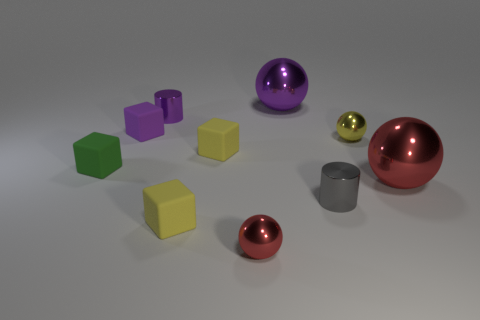What color is the other tiny metal object that is the same shape as the tiny yellow metallic thing?
Your answer should be very brief. Red. There is a matte cube that is to the left of the purple matte block; is it the same size as the large purple metallic sphere?
Offer a very short reply. No. What is the size of the metallic cylinder on the right side of the small ball that is in front of the tiny gray metallic cylinder?
Your response must be concise. Small. Is the gray cylinder made of the same material as the big thing that is behind the tiny purple rubber thing?
Ensure brevity in your answer.  Yes. Are there fewer small purple blocks behind the big purple metallic sphere than big metallic objects behind the purple matte block?
Provide a short and direct response. Yes. There is another big sphere that is the same material as the big red sphere; what is its color?
Provide a short and direct response. Purple. There is a small purple rubber cube in front of the small purple shiny thing; are there any tiny cubes that are to the right of it?
Make the answer very short. Yes. The other metallic cylinder that is the same size as the gray metal cylinder is what color?
Your answer should be very brief. Purple. What number of things are big gray spheres or big red metallic balls?
Ensure brevity in your answer.  1. What size is the purple matte cube behind the tiny metallic sphere that is to the left of the metallic thing that is behind the tiny purple metal object?
Give a very brief answer. Small. 